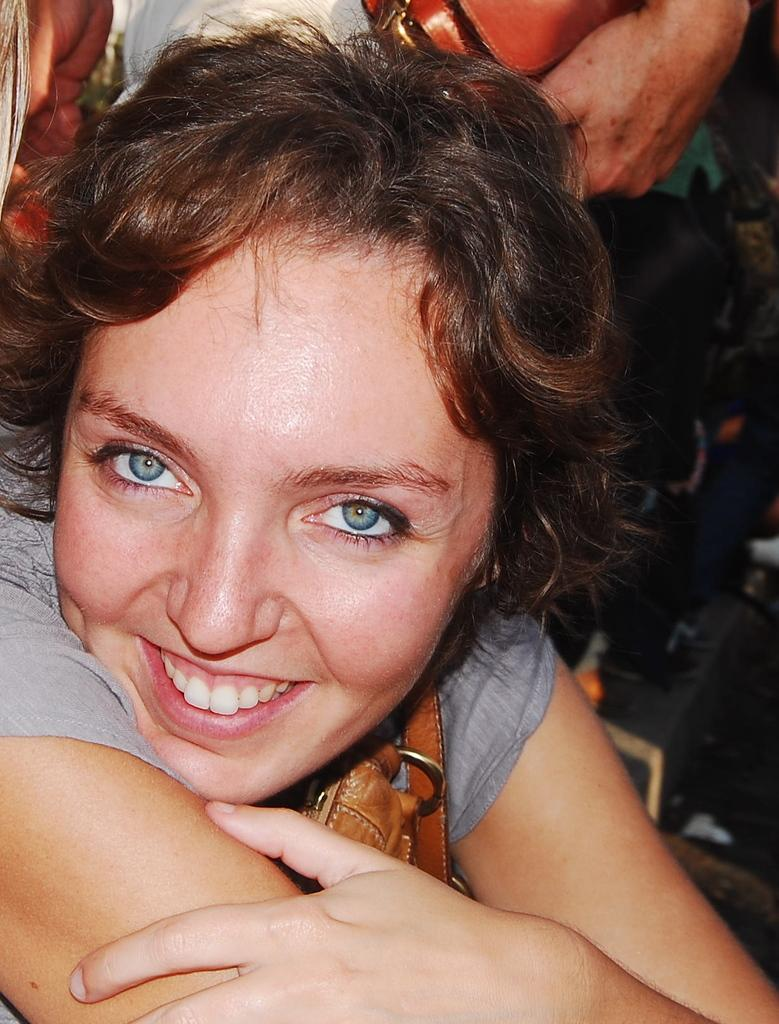Who is present in the image? There is a woman in the image. What is the woman doing in the image? The woman is smiling in the image. Can you describe the background of the image? There are persons in the background of the image. What type of mist can be seen surrounding the lake in the image? There is no mist or lake present in the image; it features a woman smiling with persons in the background. How is the woman using the comb in the image? There is no comb present in the image, so it cannot be determined how the woman might be using it. 